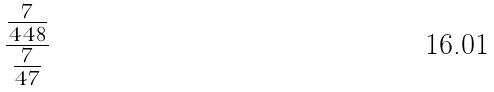<formula> <loc_0><loc_0><loc_500><loc_500>\frac { \frac { 7 } { 4 4 8 } } { \frac { 7 } { 4 7 } }</formula> 